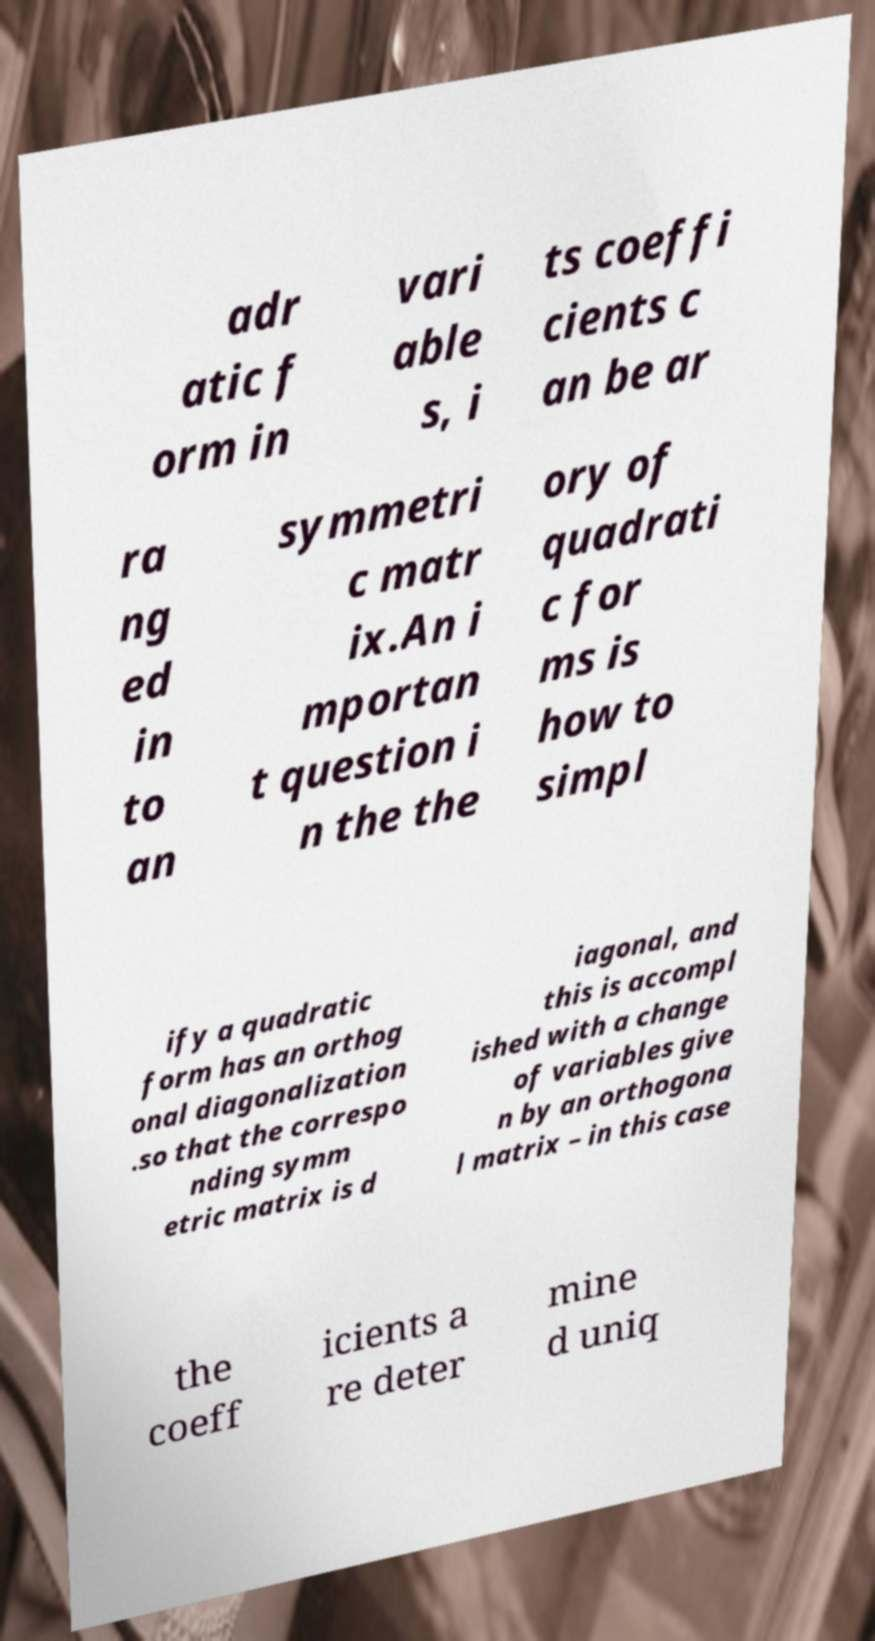Could you extract and type out the text from this image? adr atic f orm in vari able s, i ts coeffi cients c an be ar ra ng ed in to an symmetri c matr ix.An i mportan t question i n the the ory of quadrati c for ms is how to simpl ify a quadratic form has an orthog onal diagonalization .so that the correspo nding symm etric matrix is d iagonal, and this is accompl ished with a change of variables give n by an orthogona l matrix – in this case the coeff icients a re deter mine d uniq 